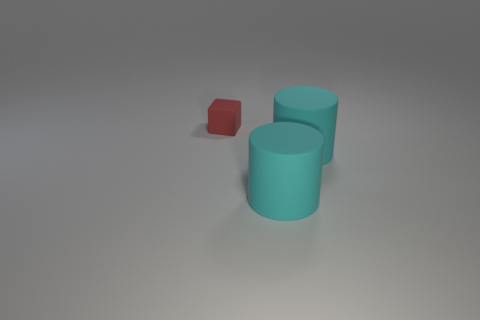Is there any other thing that is the same size as the cube?
Your response must be concise. No. What number of other small objects have the same material as the red object?
Give a very brief answer. 0. What is the color of the tiny rubber cube?
Ensure brevity in your answer.  Red. How many other things are made of the same material as the small object?
Your response must be concise. 2. What number of other objects are there of the same size as the red object?
Your answer should be very brief. 0. What number of balls are either small red objects or cyan objects?
Your answer should be compact. 0. How many green objects are either matte blocks or large matte cylinders?
Your answer should be very brief. 0. Is there a cylinder?
Your answer should be very brief. Yes. How many cylinders are the same size as the red matte object?
Your response must be concise. 0. Are there an equal number of red things right of the block and tiny red shiny cylinders?
Your answer should be compact. Yes. 